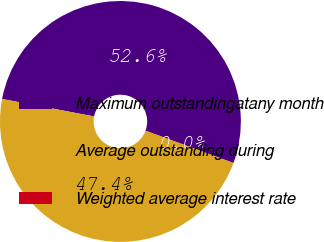<chart> <loc_0><loc_0><loc_500><loc_500><pie_chart><fcel>Maximum outstandingatany month<fcel>Average outstanding during<fcel>Weighted average interest rate<nl><fcel>52.61%<fcel>47.38%<fcel>0.01%<nl></chart> 